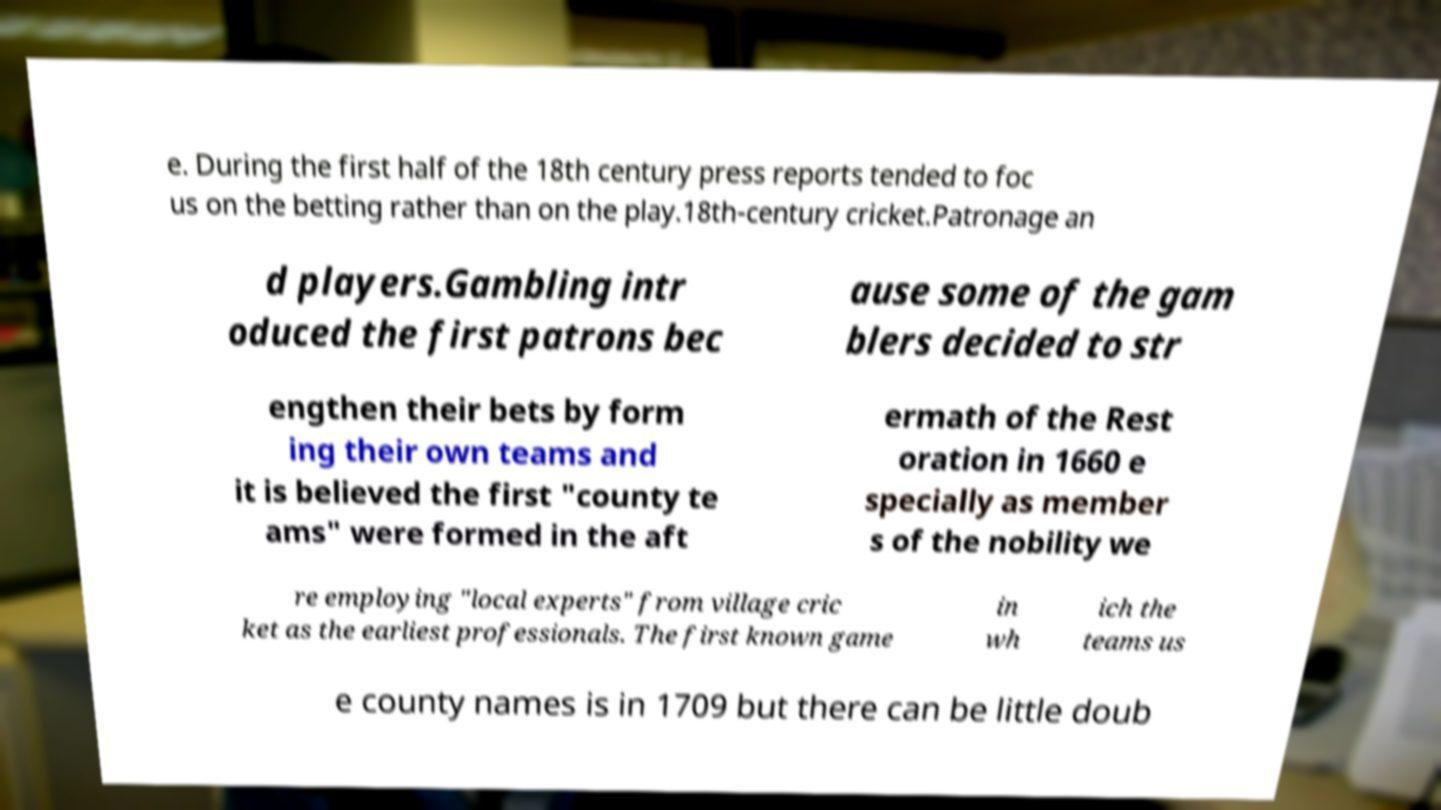Can you read and provide the text displayed in the image?This photo seems to have some interesting text. Can you extract and type it out for me? e. During the first half of the 18th century press reports tended to foc us on the betting rather than on the play.18th-century cricket.Patronage an d players.Gambling intr oduced the first patrons bec ause some of the gam blers decided to str engthen their bets by form ing their own teams and it is believed the first "county te ams" were formed in the aft ermath of the Rest oration in 1660 e specially as member s of the nobility we re employing "local experts" from village cric ket as the earliest professionals. The first known game in wh ich the teams us e county names is in 1709 but there can be little doub 